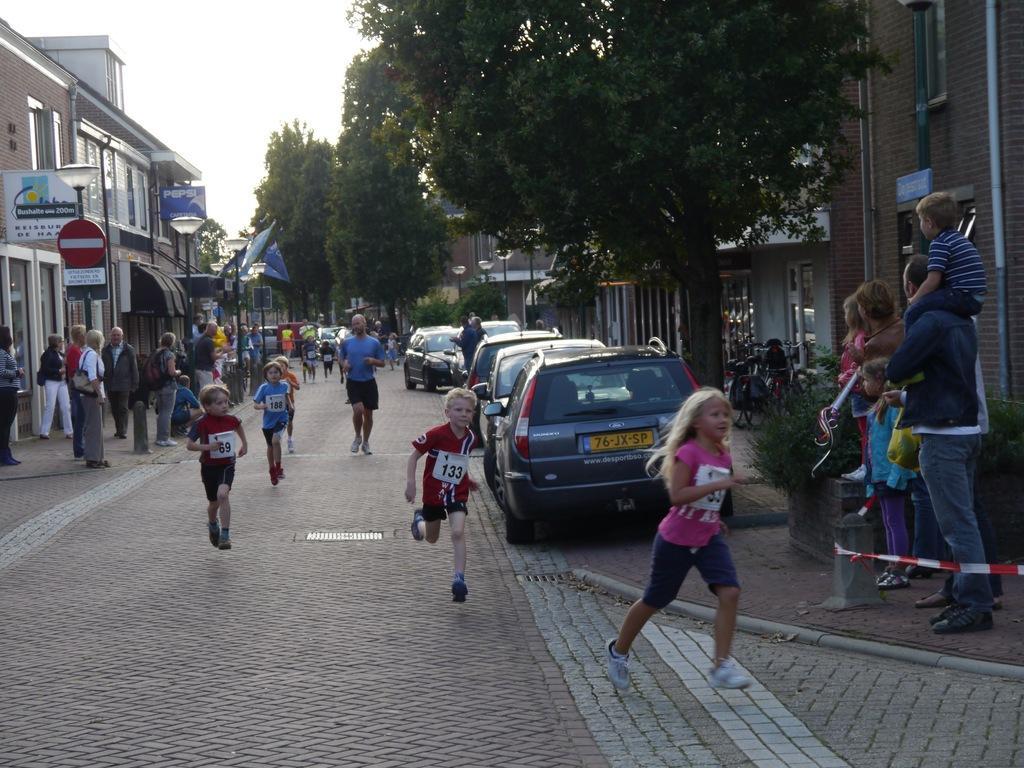Can you describe this image briefly? In the image there are few people running on the road. On the left side of the image there is a footpath with few people are standing. And also there are poles with lamps, sign boards and posters. There are buildings with walls and glass windows. And on the right side of the image there is a footpath with few people, bicycles, trees and poles with lamps. And also there are buildings with walls and windows. In the background there are many trees. At the top of the image there is sky. 